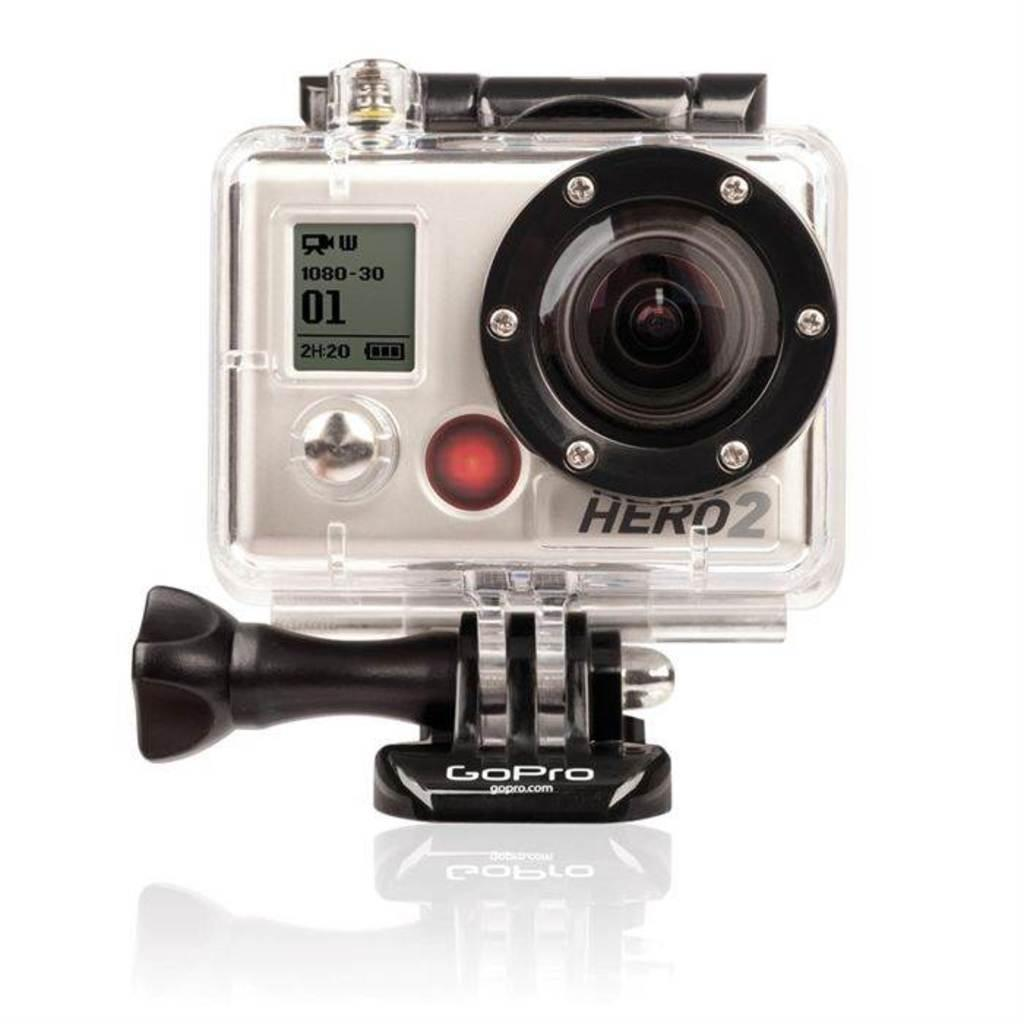What is the main object in the image? There is a camera in the image. What features can be seen on the camera? The camera has a screen and a lens. Is there any text on the camera? Yes, there is text written on the camera. What is the color of the surface the camera is placed on? The camera is on a white surface. What color is the background of the image? The background of the image is white. Can you see a nest with squirrels and honey in the image? No, there is no nest, squirrels, or honey present in the image; it features a camera on a white surface with a white background. 